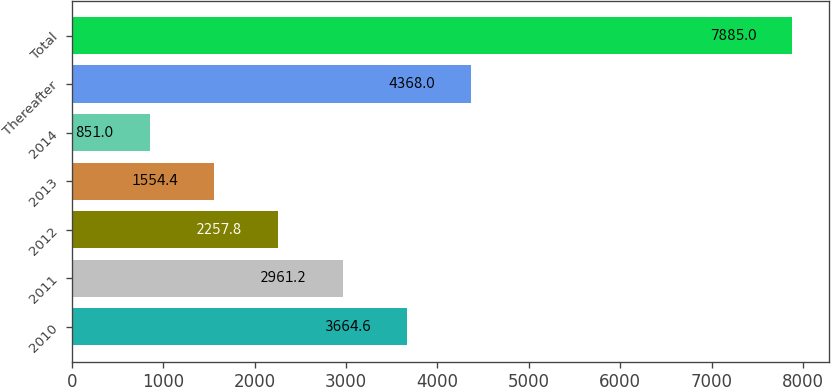Convert chart. <chart><loc_0><loc_0><loc_500><loc_500><bar_chart><fcel>2010<fcel>2011<fcel>2012<fcel>2013<fcel>2014<fcel>Thereafter<fcel>Total<nl><fcel>3664.6<fcel>2961.2<fcel>2257.8<fcel>1554.4<fcel>851<fcel>4368<fcel>7885<nl></chart> 